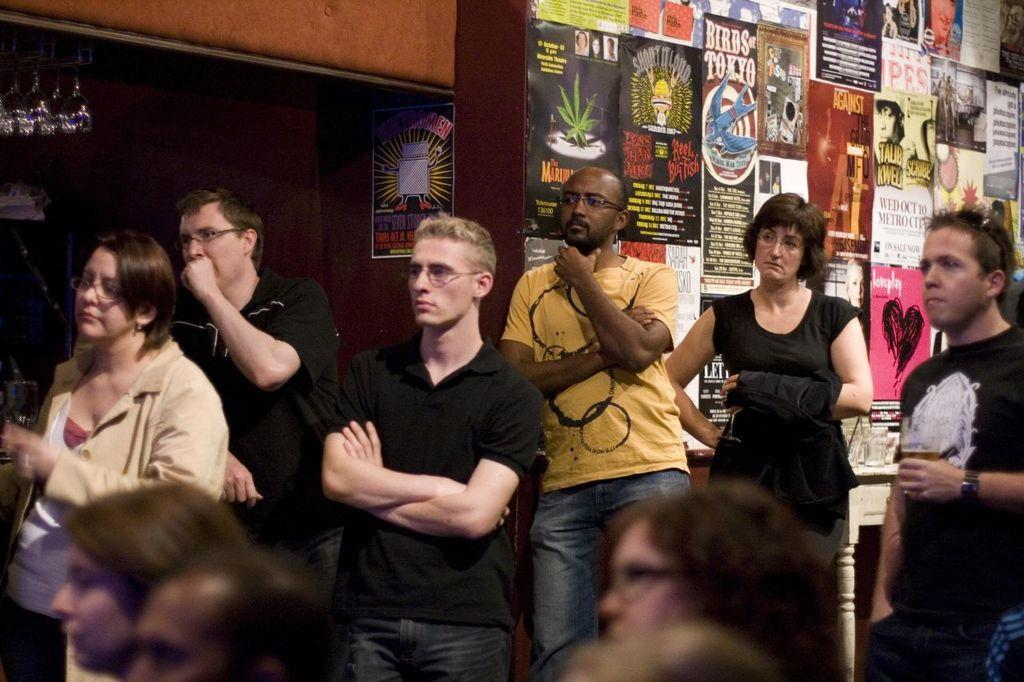What is happening in the image? There are people standing in the image. What can be seen on the wall in the background? There are posters on the wall in the background. Where are the glasses located in the image? The glasses are visible in the top left corner of the image. What type of bat is hanging from the ceiling in the image? There is no bat present in the image; it only features people standing and posters on the wall. 